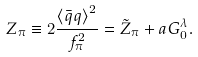Convert formula to latex. <formula><loc_0><loc_0><loc_500><loc_500>Z _ { \pi } \equiv 2 \frac { { \langle \bar { q } q \rangle } ^ { 2 } } { f _ { \pi } ^ { 2 } } = \tilde { Z } _ { \pi } + a G ^ { \lambda } _ { 0 } .</formula> 